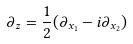<formula> <loc_0><loc_0><loc_500><loc_500>\partial _ { z } = \frac { 1 } { 2 } ( \partial _ { x _ { 1 } } - i \partial _ { x _ { 2 } } )</formula> 